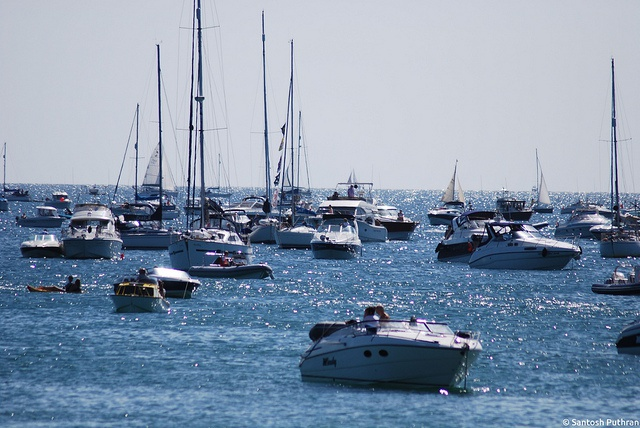Describe the objects in this image and their specific colors. I can see boat in lightgray, navy, black, and gray tones, boat in lightgray, black, darkblue, and blue tones, boat in lightgray, navy, darkblue, and black tones, boat in lightgray, navy, black, and darkblue tones, and boat in lightgray, black, gray, darkgray, and navy tones in this image. 